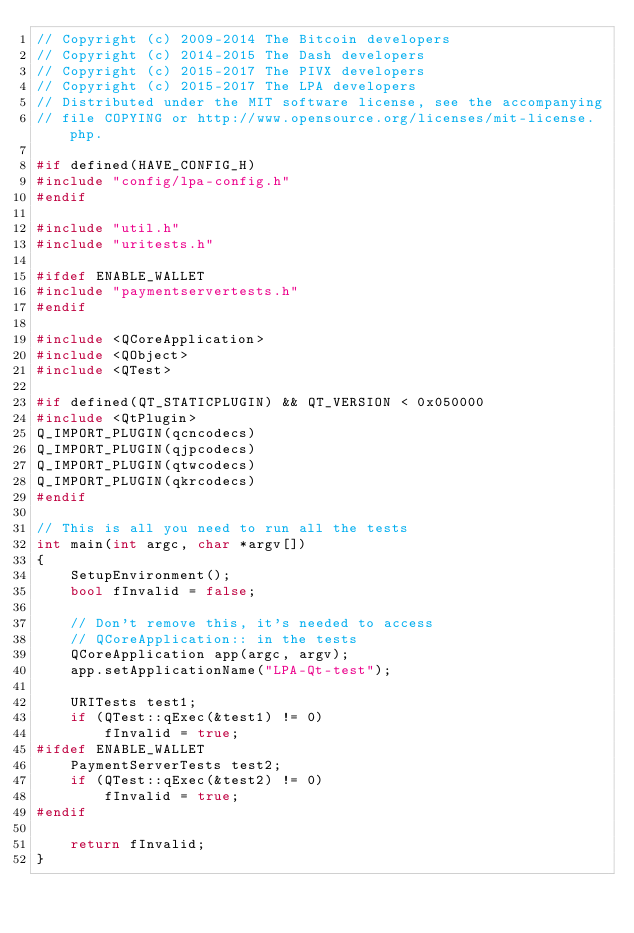Convert code to text. <code><loc_0><loc_0><loc_500><loc_500><_C++_>// Copyright (c) 2009-2014 The Bitcoin developers
// Copyright (c) 2014-2015 The Dash developers
// Copyright (c) 2015-2017 The PIVX developers 
// Copyright (c) 2015-2017 The LPA developers
// Distributed under the MIT software license, see the accompanying
// file COPYING or http://www.opensource.org/licenses/mit-license.php.

#if defined(HAVE_CONFIG_H)
#include "config/lpa-config.h"
#endif

#include "util.h"
#include "uritests.h"

#ifdef ENABLE_WALLET
#include "paymentservertests.h"
#endif

#include <QCoreApplication>
#include <QObject>
#include <QTest>

#if defined(QT_STATICPLUGIN) && QT_VERSION < 0x050000
#include <QtPlugin>
Q_IMPORT_PLUGIN(qcncodecs)
Q_IMPORT_PLUGIN(qjpcodecs)
Q_IMPORT_PLUGIN(qtwcodecs)
Q_IMPORT_PLUGIN(qkrcodecs)
#endif

// This is all you need to run all the tests
int main(int argc, char *argv[])
{
    SetupEnvironment();
    bool fInvalid = false;

    // Don't remove this, it's needed to access
    // QCoreApplication:: in the tests
    QCoreApplication app(argc, argv);
    app.setApplicationName("LPA-Qt-test");

    URITests test1;
    if (QTest::qExec(&test1) != 0)
        fInvalid = true;
#ifdef ENABLE_WALLET
    PaymentServerTests test2;
    if (QTest::qExec(&test2) != 0)
        fInvalid = true;
#endif

    return fInvalid;
}
</code> 